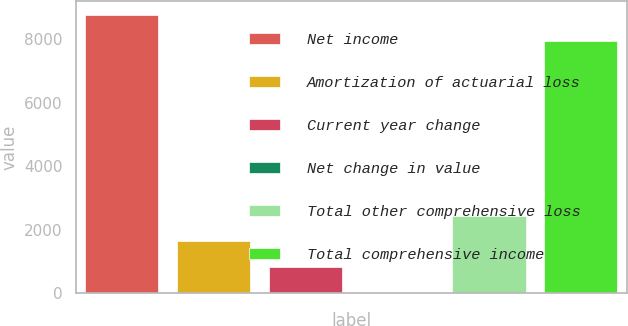Convert chart to OTSL. <chart><loc_0><loc_0><loc_500><loc_500><bar_chart><fcel>Net income<fcel>Amortization of actuarial loss<fcel>Current year change<fcel>Net change in value<fcel>Total other comprehensive loss<fcel>Total comprehensive income<nl><fcel>8756.4<fcel>1628.8<fcel>817.4<fcel>6<fcel>2440.2<fcel>7945<nl></chart> 